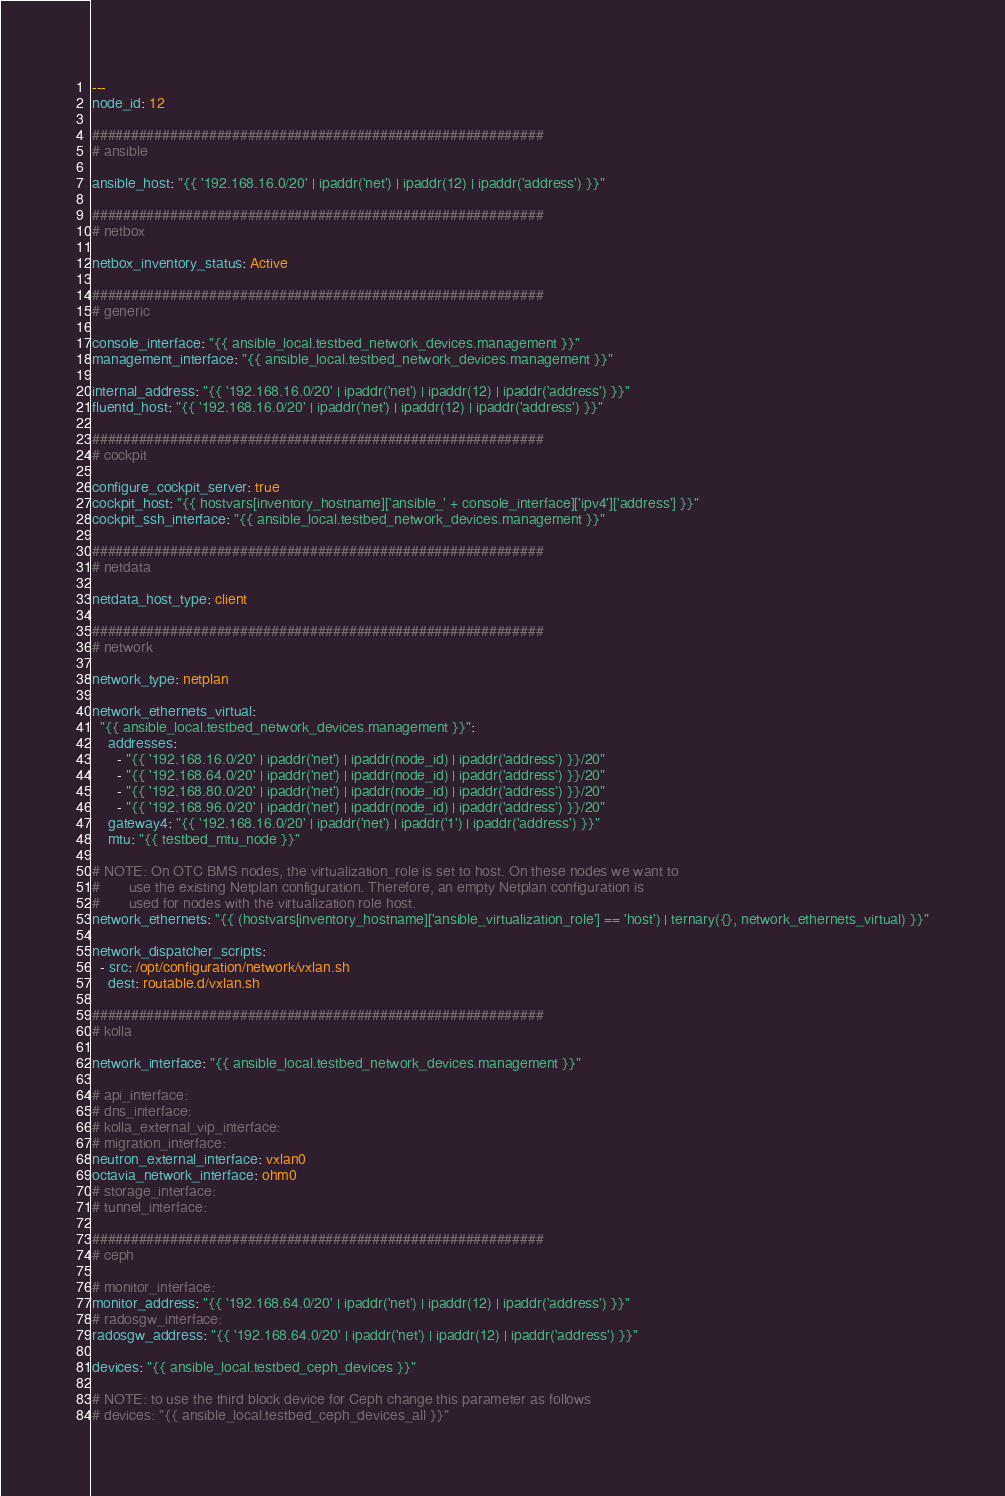<code> <loc_0><loc_0><loc_500><loc_500><_YAML_>---
node_id: 12

##########################################################
# ansible

ansible_host: "{{ '192.168.16.0/20' | ipaddr('net') | ipaddr(12) | ipaddr('address') }}"

##########################################################
# netbox

netbox_inventory_status: Active

##########################################################
# generic

console_interface: "{{ ansible_local.testbed_network_devices.management }}"
management_interface: "{{ ansible_local.testbed_network_devices.management }}"

internal_address: "{{ '192.168.16.0/20' | ipaddr('net') | ipaddr(12) | ipaddr('address') }}"
fluentd_host: "{{ '192.168.16.0/20' | ipaddr('net') | ipaddr(12) | ipaddr('address') }}"

##########################################################
# cockpit

configure_cockpit_server: true
cockpit_host: "{{ hostvars[inventory_hostname]['ansible_' + console_interface]['ipv4']['address'] }}"
cockpit_ssh_interface: "{{ ansible_local.testbed_network_devices.management }}"

##########################################################
# netdata

netdata_host_type: client

##########################################################
# network

network_type: netplan

network_ethernets_virtual:
  "{{ ansible_local.testbed_network_devices.management }}":
    addresses:
      - "{{ '192.168.16.0/20' | ipaddr('net') | ipaddr(node_id) | ipaddr('address') }}/20"
      - "{{ '192.168.64.0/20' | ipaddr('net') | ipaddr(node_id) | ipaddr('address') }}/20"
      - "{{ '192.168.80.0/20' | ipaddr('net') | ipaddr(node_id) | ipaddr('address') }}/20"
      - "{{ '192.168.96.0/20' | ipaddr('net') | ipaddr(node_id) | ipaddr('address') }}/20"
    gateway4: "{{ '192.168.16.0/20' | ipaddr('net') | ipaddr('1') | ipaddr('address') }}"
    mtu: "{{ testbed_mtu_node }}"

# NOTE: On OTC BMS nodes, the virtualization_role is set to host. On these nodes we want to
#       use the existing Netplan configuration. Therefore, an empty Netplan configuration is
#       used for nodes with the virtualization role host.
network_ethernets: "{{ (hostvars[inventory_hostname]['ansible_virtualization_role'] == 'host') | ternary({}, network_ethernets_virtual) }}"

network_dispatcher_scripts:
  - src: /opt/configuration/network/vxlan.sh
    dest: routable.d/vxlan.sh

##########################################################
# kolla

network_interface: "{{ ansible_local.testbed_network_devices.management }}"

# api_interface:
# dns_interface:
# kolla_external_vip_interface:
# migration_interface:
neutron_external_interface: vxlan0
octavia_network_interface: ohm0
# storage_interface:
# tunnel_interface:

##########################################################
# ceph

# monitor_interface:
monitor_address: "{{ '192.168.64.0/20' | ipaddr('net') | ipaddr(12) | ipaddr('address') }}"
# radosgw_interface:
radosgw_address: "{{ '192.168.64.0/20' | ipaddr('net') | ipaddr(12) | ipaddr('address') }}"

devices: "{{ ansible_local.testbed_ceph_devices }}"

# NOTE: to use the third block device for Ceph change this parameter as follows
# devices: "{{ ansible_local.testbed_ceph_devices_all }}"
</code> 